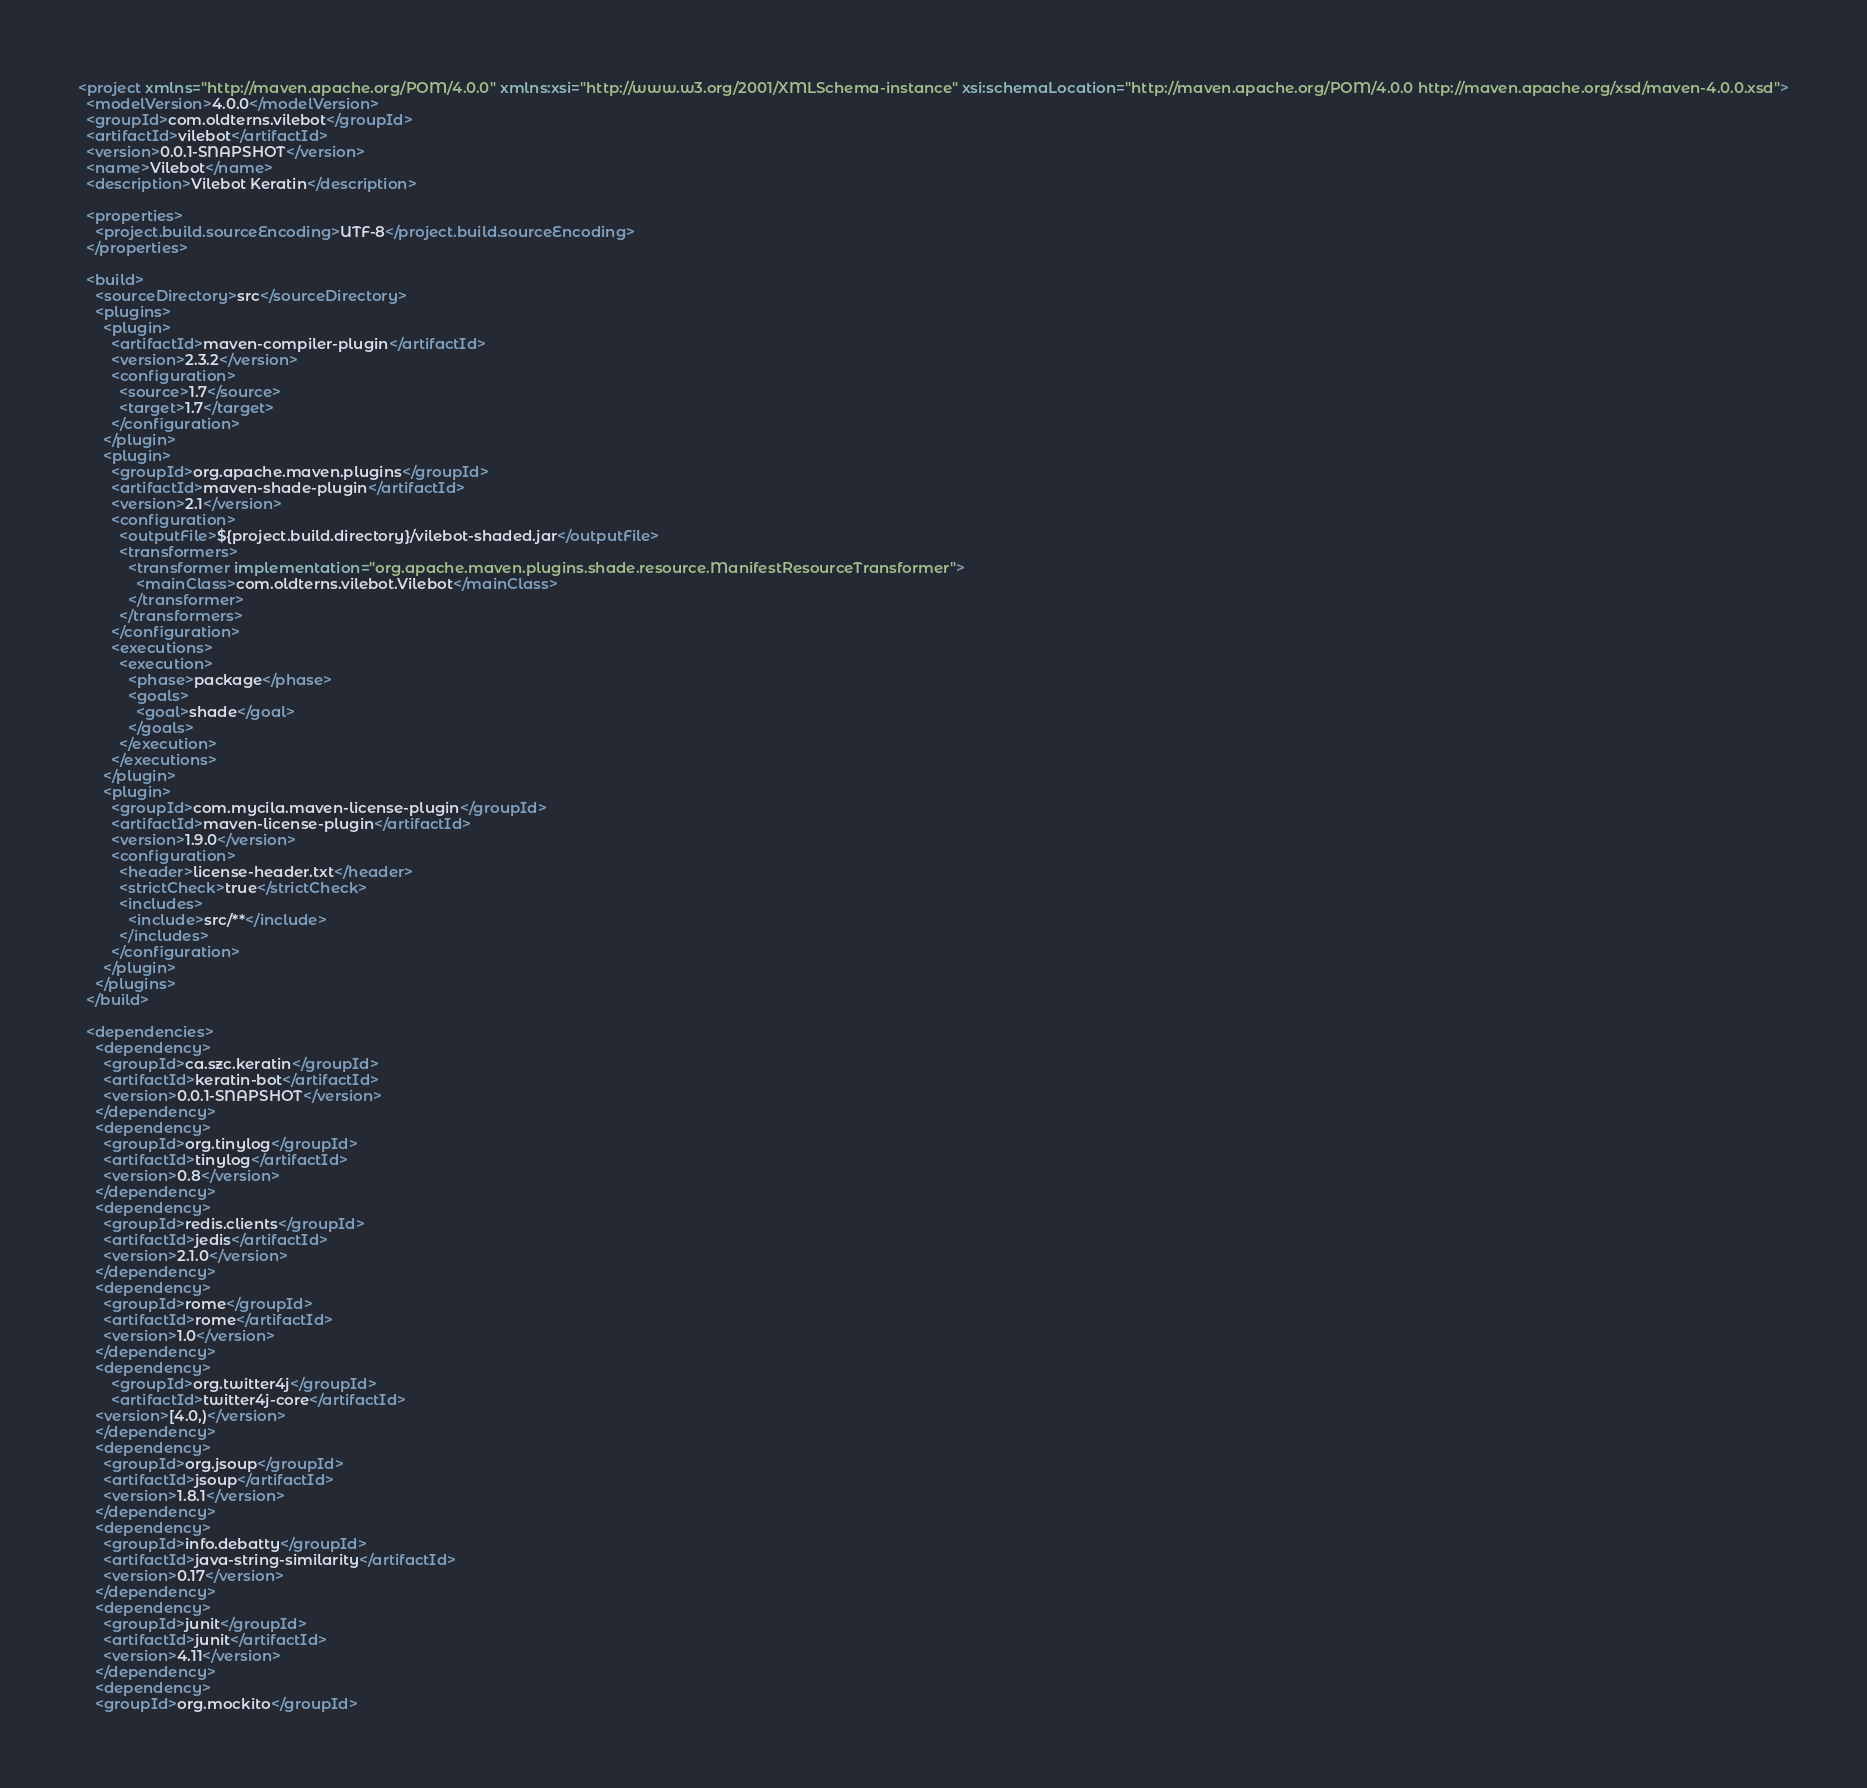Convert code to text. <code><loc_0><loc_0><loc_500><loc_500><_XML_><project xmlns="http://maven.apache.org/POM/4.0.0" xmlns:xsi="http://www.w3.org/2001/XMLSchema-instance" xsi:schemaLocation="http://maven.apache.org/POM/4.0.0 http://maven.apache.org/xsd/maven-4.0.0.xsd">
  <modelVersion>4.0.0</modelVersion>
  <groupId>com.oldterns.vilebot</groupId>
  <artifactId>vilebot</artifactId>
  <version>0.0.1-SNAPSHOT</version>
  <name>Vilebot</name>
  <description>Vilebot Keratin</description>

  <properties>
    <project.build.sourceEncoding>UTF-8</project.build.sourceEncoding>
  </properties>

  <build>
    <sourceDirectory>src</sourceDirectory>
    <plugins>
      <plugin>
        <artifactId>maven-compiler-plugin</artifactId>
        <version>2.3.2</version>
        <configuration>
          <source>1.7</source>
          <target>1.7</target>
        </configuration>
      </plugin>
      <plugin>
        <groupId>org.apache.maven.plugins</groupId>
        <artifactId>maven-shade-plugin</artifactId>
        <version>2.1</version>
        <configuration>
          <outputFile>${project.build.directory}/vilebot-shaded.jar</outputFile>
          <transformers>
            <transformer implementation="org.apache.maven.plugins.shade.resource.ManifestResourceTransformer">
              <mainClass>com.oldterns.vilebot.Vilebot</mainClass>
            </transformer>
          </transformers>
        </configuration>
        <executions>
          <execution>
            <phase>package</phase>
            <goals>
              <goal>shade</goal>
            </goals>
          </execution>
        </executions>
      </plugin>
      <plugin>
        <groupId>com.mycila.maven-license-plugin</groupId>
        <artifactId>maven-license-plugin</artifactId>
        <version>1.9.0</version>
        <configuration>
          <header>license-header.txt</header>
          <strictCheck>true</strictCheck>
          <includes>
            <include>src/**</include>
          </includes>
        </configuration>
      </plugin>
    </plugins>
  </build>

  <dependencies>
    <dependency>
      <groupId>ca.szc.keratin</groupId>
      <artifactId>keratin-bot</artifactId>
      <version>0.0.1-SNAPSHOT</version>
    </dependency>
    <dependency>
      <groupId>org.tinylog</groupId>
      <artifactId>tinylog</artifactId>
      <version>0.8</version>
    </dependency>
    <dependency>
      <groupId>redis.clients</groupId>
      <artifactId>jedis</artifactId>
      <version>2.1.0</version>
    </dependency>
    <dependency>
      <groupId>rome</groupId>
      <artifactId>rome</artifactId>
      <version>1.0</version>
    </dependency>
    <dependency>
    	<groupId>org.twitter4j</groupId>
    	<artifactId>twitter4j-core</artifactId>
	<version>[4.0,)</version>
    </dependency>
    <dependency>
      <groupId>org.jsoup</groupId>
      <artifactId>jsoup</artifactId>
      <version>1.8.1</version>
    </dependency>
    <dependency>
      <groupId>info.debatty</groupId>
      <artifactId>java-string-similarity</artifactId>
      <version>0.17</version>
    </dependency>
    <dependency>
      <groupId>junit</groupId>
      <artifactId>junit</artifactId>
      <version>4.11</version>
    </dependency>
	<dependency>
    <groupId>org.mockito</groupId></code> 